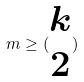Convert formula to latex. <formula><loc_0><loc_0><loc_500><loc_500>m \geq ( \begin{matrix} k \\ 2 \end{matrix} )</formula> 